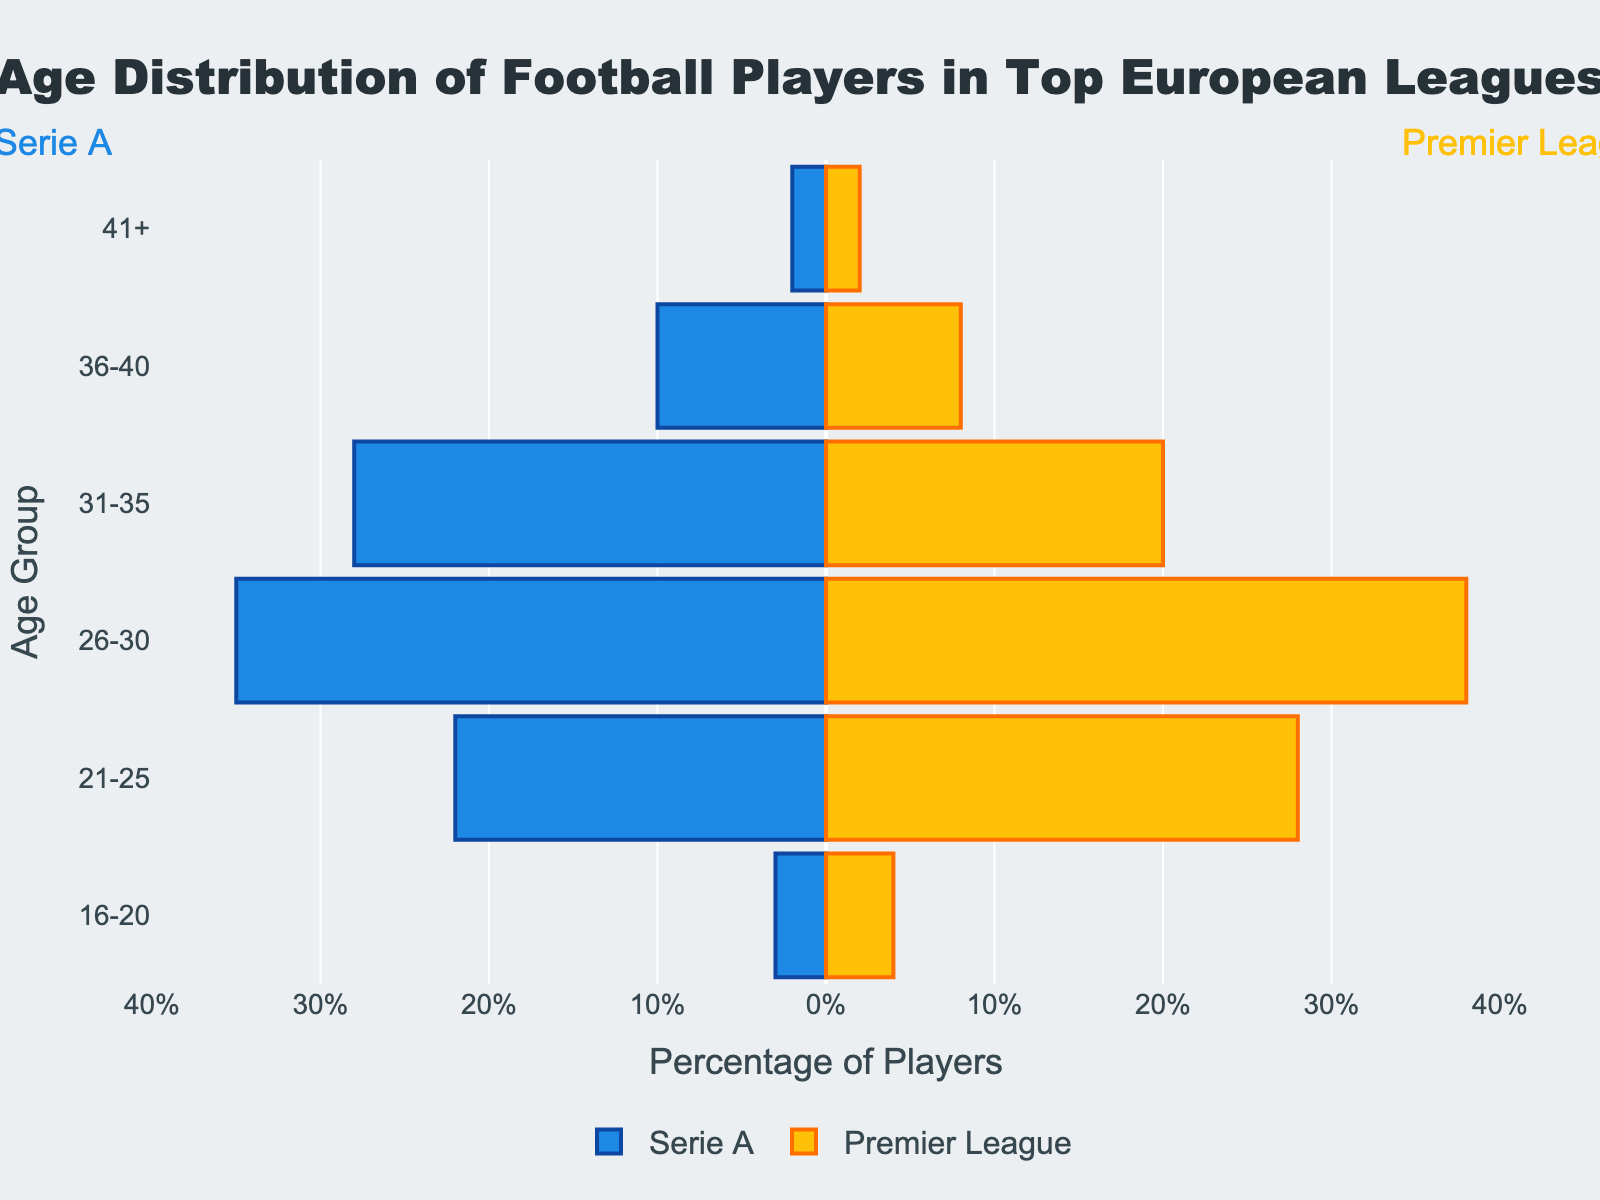What is the title of the figure? The title is usually located at the top center of the figure and is meant to describe the content of the chart. The text "Age Distribution of Football Players in Top European Leagues" is found in this position.
Answer: Age Distribution of Football Players in Top European Leagues What are the age groups listed in the figure? The age groups can be found along the y-axis. The groups listed are "16-20," "21-25," "26-30," "31-35," "36-40," and "41+".
Answer: 16-20, 21-25, 26-30, 31-35, 36-40, 41+ Which league has more players in the 26-30 age group? To determine this, look at the bars corresponding to the "26-30" age group. On the right side (Premier League), there is a yellow bar extending up to 38, while on the left side (Serie A) the blue bar extends to 35. Therefore, the Premier League has more players.
Answer: Premier League What is the difference in the number of players between Serie A and Premier League in the 31-35 age group? Locate the bars corresponding to the "31-35" age group for both leagues. The Serie A bar extends to 28, and the Premier League bar extends to 20. Subtract 20 from 28 to get the difference.
Answer: 8 In which age group do Serie A players have the least representation? Look for the shortest blue bar to the left. The age group "16-20" has the shortest bar with a value of 3, indicating the least representation.
Answer: 16-20 How many players combined are in the 36-40 age group for both leagues? Add the values of the bars corresponding to the "36-40" age group. Serie A has 10 players, and Premier League has 8 players. So, 10 + 8 = 18.
Answer: 18 What is the percentage range for the x-axis in the figure? The x-axis is labeled with percentages. The range spans from -40% to 40%, with tick marks at -40, -30, -20, -10, 0, 10, 20, 30, and 40.
Answer: -40% to 40% Which league has a higher percentage of players aged 41+? Look at the bars representing the "41+" age group. Both Serie A and Premier League have bars extending to 2, indicating an equal percentage of players in this age group.
Answer: Both are equal What is the total number of players aged 21-25 across both leagues? Add the values of the bars corresponding to the "21-25" age group. Serie A has 22 players, and Premier League has 28 players. Total is 22 + 28 = 50.
Answer: 50 What can you infer about the age distribution of football players in the 26-30 age group in both leagues? The bars for the "26-30" age group are the longest in both leagues, with 35 for Serie A and 38 for Premier League. This indicates that the majority of football players in the top European leagues are aged 26-30.
Answer: Majority are aged 26-30 